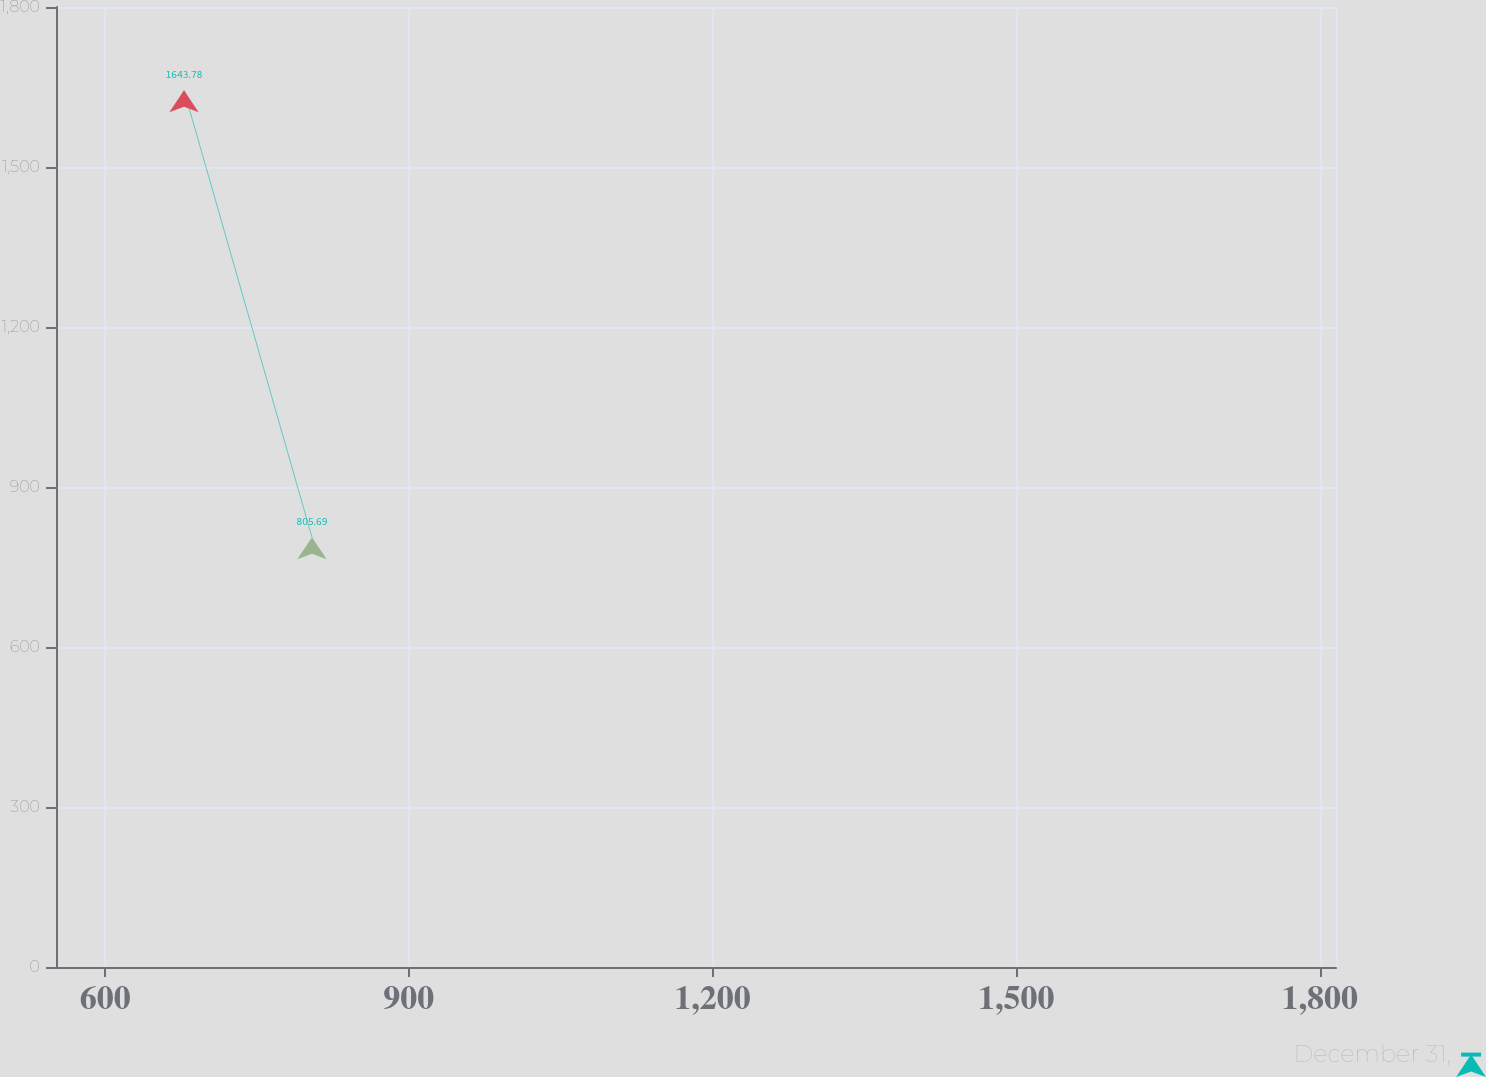Convert chart. <chart><loc_0><loc_0><loc_500><loc_500><line_chart><ecel><fcel>December 31,<nl><fcel>677.9<fcel>1643.78<nl><fcel>804.35<fcel>805.69<nl><fcel>1942.4<fcel>541.68<nl></chart> 